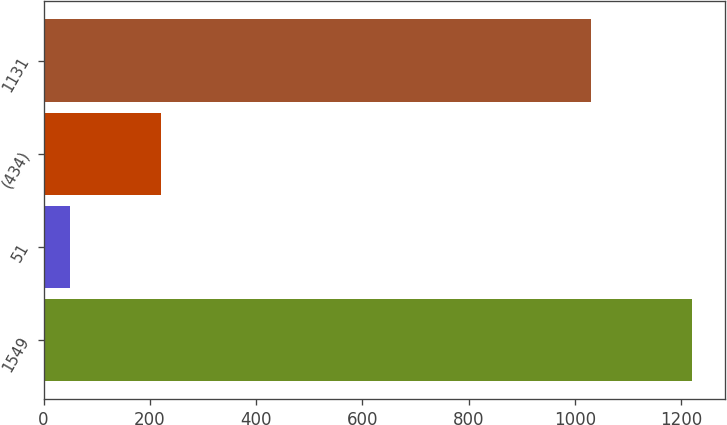Convert chart to OTSL. <chart><loc_0><loc_0><loc_500><loc_500><bar_chart><fcel>1549<fcel>51<fcel>(434)<fcel>1131<nl><fcel>1221<fcel>49<fcel>221<fcel>1030<nl></chart> 